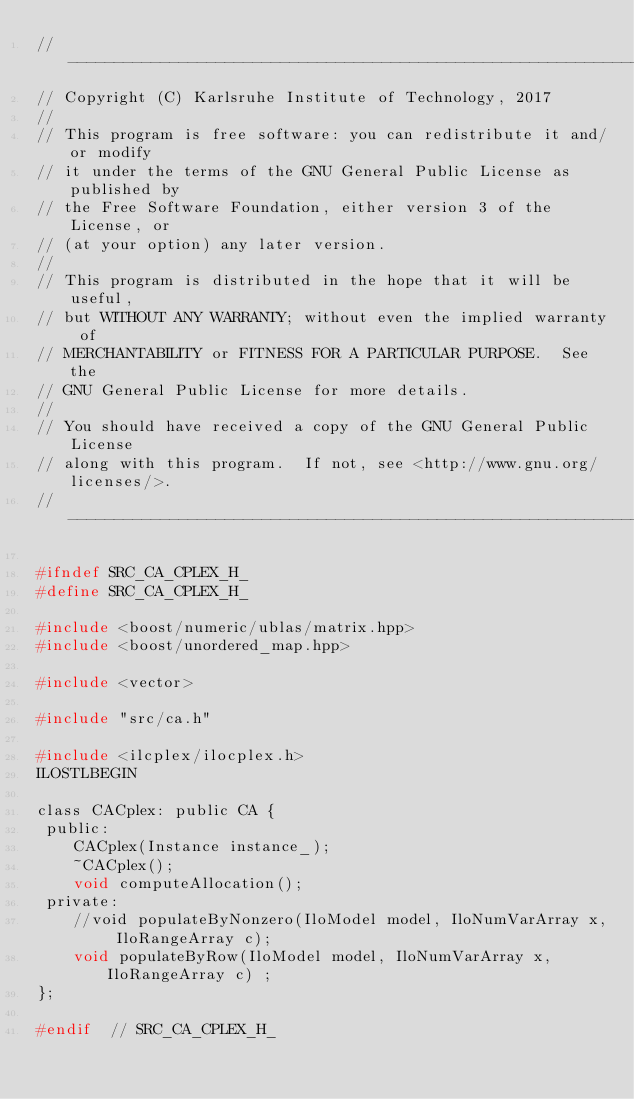<code> <loc_0><loc_0><loc_500><loc_500><_C_>// --------------------------------------------------------------------------
// Copyright (C) Karlsruhe Institute of Technology, 2017
//
// This program is free software: you can redistribute it and/or modify
// it under the terms of the GNU General Public License as published by
// the Free Software Foundation, either version 3 of the License, or
// (at your option) any later version.
//
// This program is distributed in the hope that it will be useful,
// but WITHOUT ANY WARRANTY; without even the implied warranty of
// MERCHANTABILITY or FITNESS FOR A PARTICULAR PURPOSE.  See the
// GNU General Public License for more details.
//
// You should have received a copy of the GNU General Public License
// along with this program.  If not, see <http://www.gnu.org/licenses/>.
// --------------------------------------------------------------------------

#ifndef SRC_CA_CPLEX_H_
#define SRC_CA_CPLEX_H_

#include <boost/numeric/ublas/matrix.hpp>
#include <boost/unordered_map.hpp>

#include <vector>

#include "src/ca.h"

#include <ilcplex/ilocplex.h>
ILOSTLBEGIN

class CACplex: public CA {
 public:
    CACplex(Instance instance_);
    ~CACplex();
    void computeAllocation();
 private:
    //void populateByNonzero(IloModel model, IloNumVarArray x, IloRangeArray c);
    void populateByRow(IloModel model, IloNumVarArray x, IloRangeArray c) ;
};

#endif  // SRC_CA_CPLEX_H_
</code> 